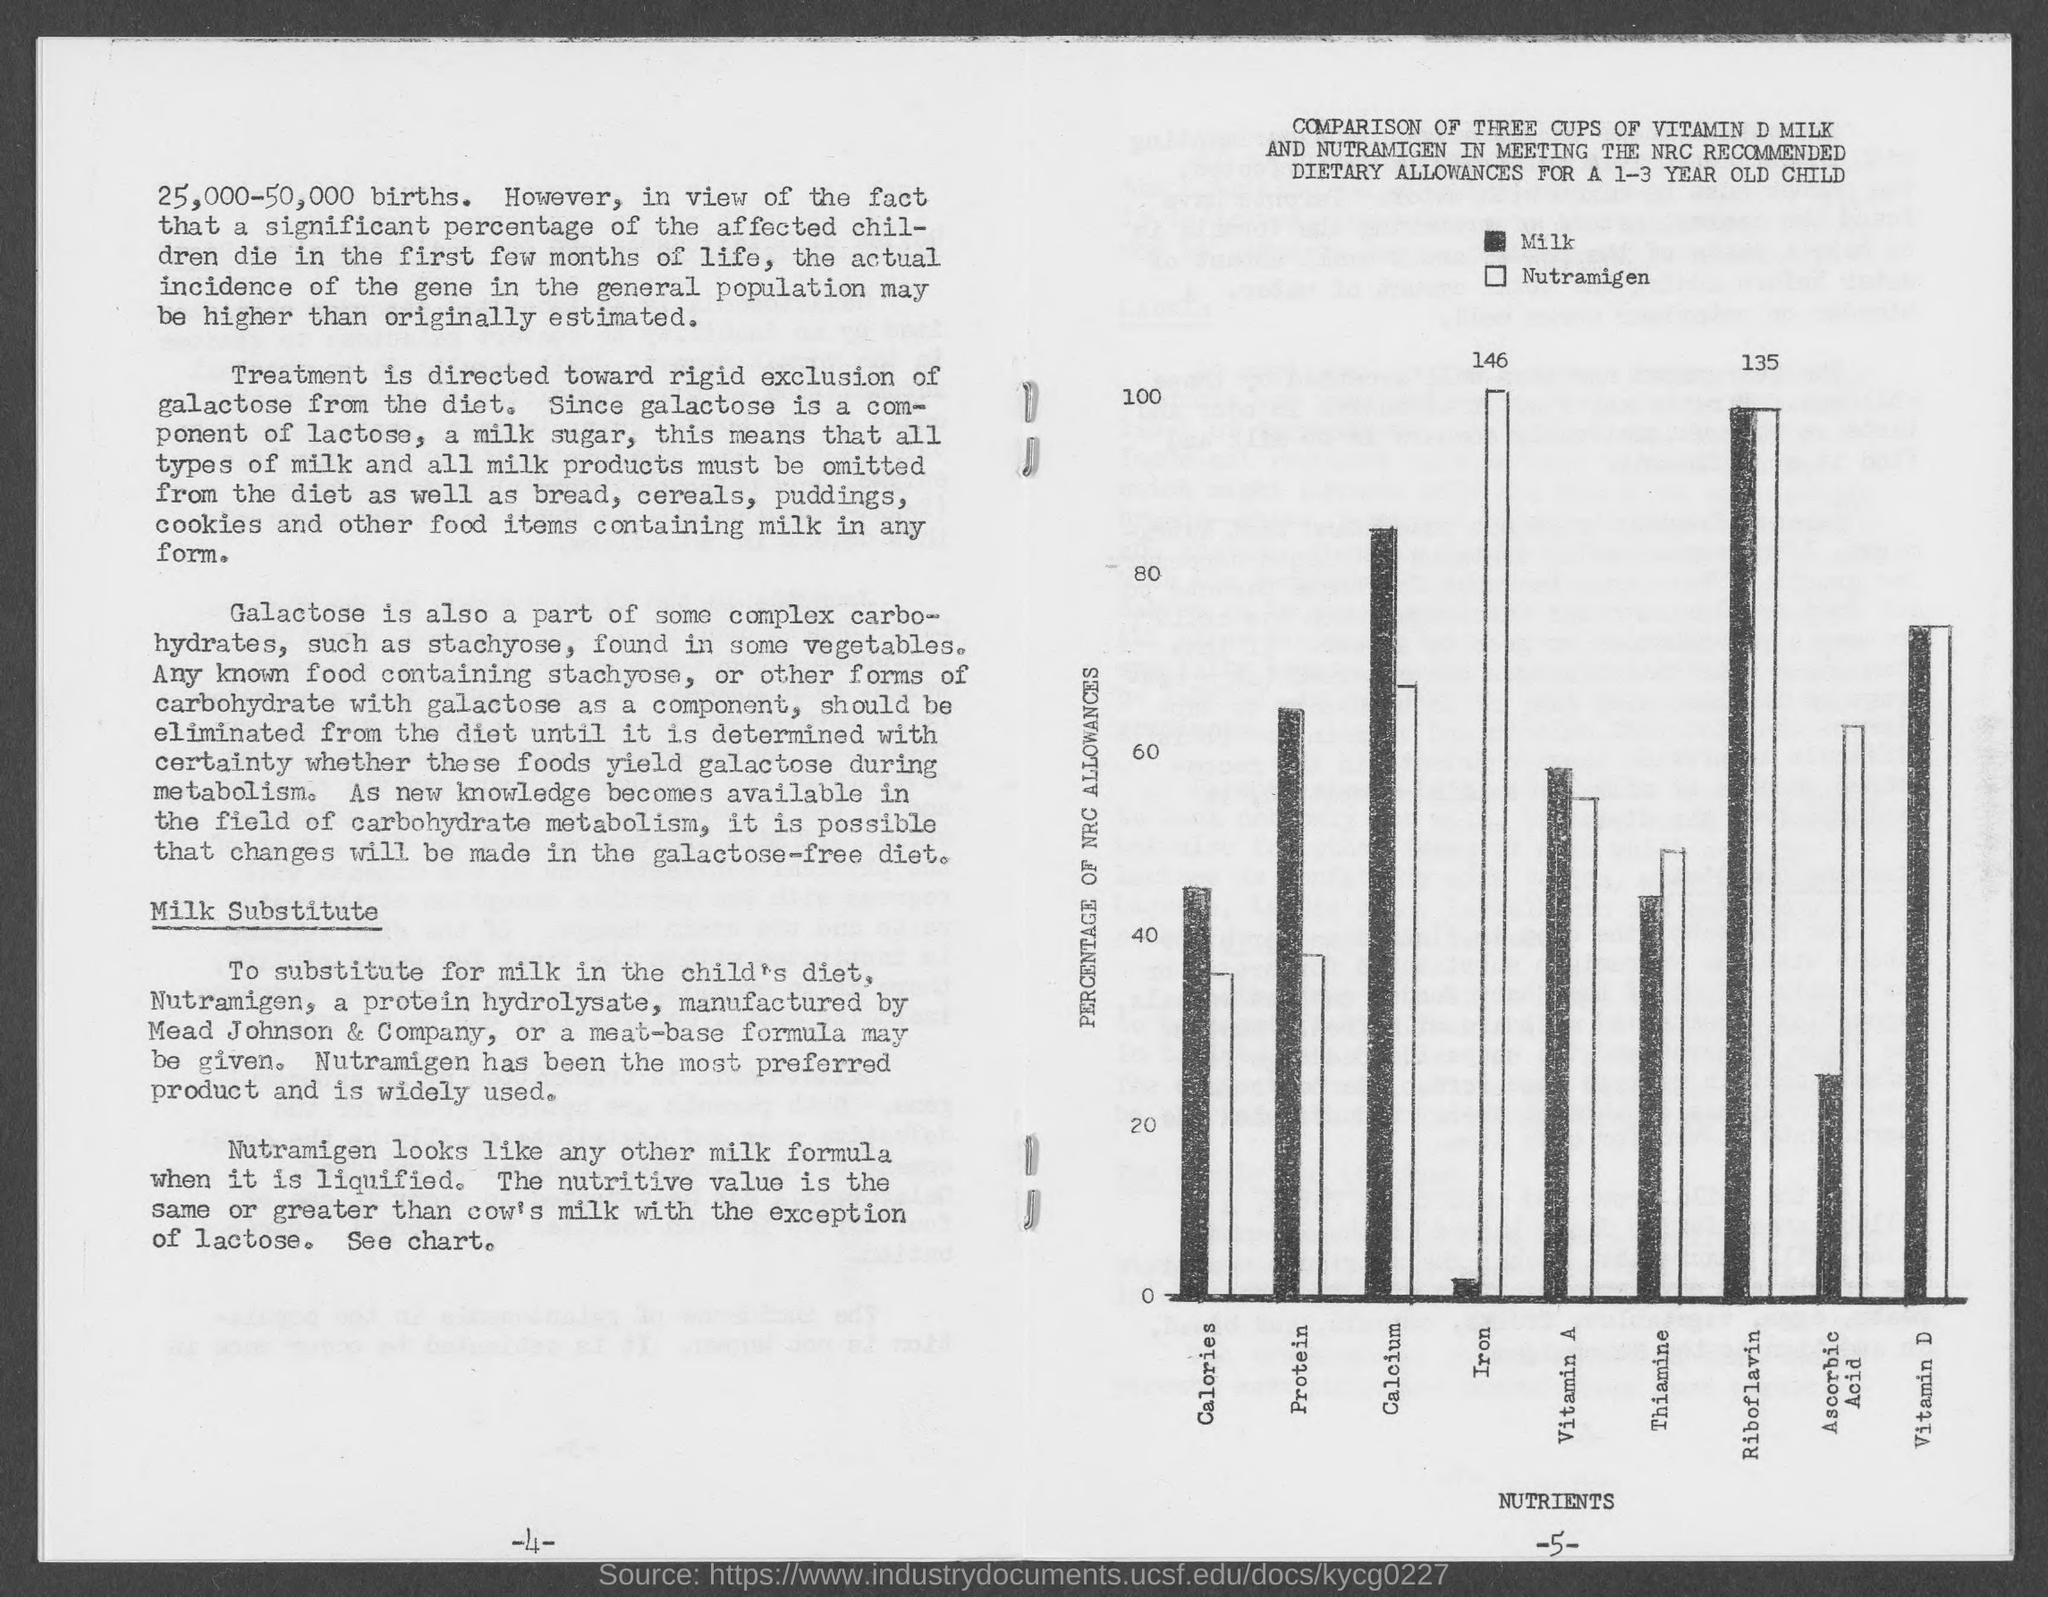What is the number of births mentioned?
Make the answer very short. 25,000-50,000. What is rigidly excluded from diet?
Your answer should be very brief. Galactose. What is the common component of lactose?
Offer a terse response. Galactose. Nutramigen is manufactured by which company?
Keep it short and to the point. Mead johnson & company. What looks like any other milk formula when liquified?
Offer a terse response. Nutramigen. What does the x-axis represent?
Offer a very short reply. Nutrients. What does the y-axis represent?
Make the answer very short. Percentage of NRC allowances. Which has more calcium milk or nutramigen?
Keep it short and to the point. Milk. 